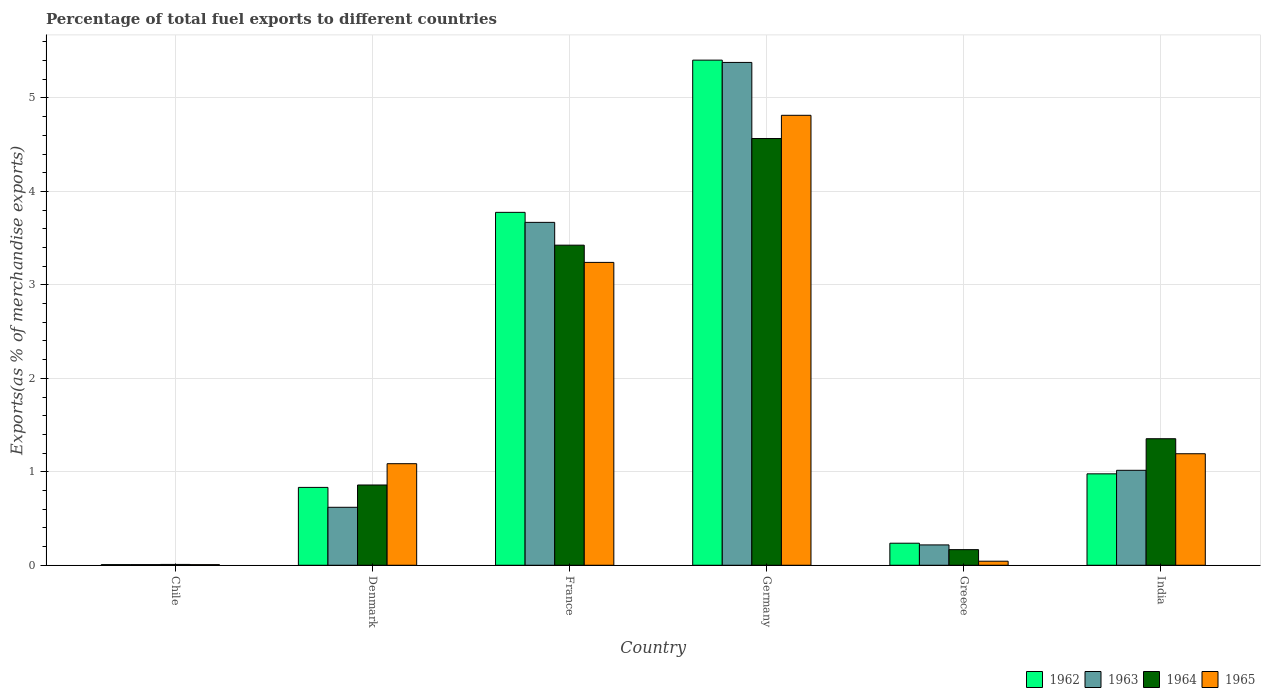How many bars are there on the 4th tick from the left?
Your answer should be compact. 4. What is the label of the 6th group of bars from the left?
Offer a very short reply. India. What is the percentage of exports to different countries in 1962 in Germany?
Keep it short and to the point. 5.4. Across all countries, what is the maximum percentage of exports to different countries in 1965?
Keep it short and to the point. 4.81. Across all countries, what is the minimum percentage of exports to different countries in 1963?
Your answer should be very brief. 0.01. In which country was the percentage of exports to different countries in 1965 minimum?
Offer a very short reply. Chile. What is the total percentage of exports to different countries in 1963 in the graph?
Ensure brevity in your answer.  10.91. What is the difference between the percentage of exports to different countries in 1962 in Greece and that in India?
Your answer should be compact. -0.74. What is the difference between the percentage of exports to different countries in 1963 in France and the percentage of exports to different countries in 1965 in India?
Make the answer very short. 2.48. What is the average percentage of exports to different countries in 1964 per country?
Your answer should be very brief. 1.73. What is the difference between the percentage of exports to different countries of/in 1965 and percentage of exports to different countries of/in 1962 in Germany?
Make the answer very short. -0.59. In how many countries, is the percentage of exports to different countries in 1964 greater than 2 %?
Your response must be concise. 2. What is the ratio of the percentage of exports to different countries in 1963 in Denmark to that in Germany?
Keep it short and to the point. 0.12. What is the difference between the highest and the second highest percentage of exports to different countries in 1965?
Your response must be concise. -2.05. What is the difference between the highest and the lowest percentage of exports to different countries in 1963?
Provide a short and direct response. 5.37. What does the 3rd bar from the right in Greece represents?
Your answer should be very brief. 1963. How many bars are there?
Make the answer very short. 24. Does the graph contain any zero values?
Offer a terse response. No. Does the graph contain grids?
Provide a short and direct response. Yes. How many legend labels are there?
Your answer should be very brief. 4. How are the legend labels stacked?
Your answer should be compact. Horizontal. What is the title of the graph?
Offer a very short reply. Percentage of total fuel exports to different countries. What is the label or title of the X-axis?
Offer a terse response. Country. What is the label or title of the Y-axis?
Make the answer very short. Exports(as % of merchandise exports). What is the Exports(as % of merchandise exports) in 1962 in Chile?
Your answer should be compact. 0.01. What is the Exports(as % of merchandise exports) in 1963 in Chile?
Offer a terse response. 0.01. What is the Exports(as % of merchandise exports) in 1964 in Chile?
Ensure brevity in your answer.  0.01. What is the Exports(as % of merchandise exports) of 1965 in Chile?
Offer a very short reply. 0.01. What is the Exports(as % of merchandise exports) in 1962 in Denmark?
Offer a terse response. 0.83. What is the Exports(as % of merchandise exports) in 1963 in Denmark?
Give a very brief answer. 0.62. What is the Exports(as % of merchandise exports) in 1964 in Denmark?
Provide a succinct answer. 0.86. What is the Exports(as % of merchandise exports) in 1965 in Denmark?
Give a very brief answer. 1.09. What is the Exports(as % of merchandise exports) of 1962 in France?
Give a very brief answer. 3.78. What is the Exports(as % of merchandise exports) of 1963 in France?
Your answer should be compact. 3.67. What is the Exports(as % of merchandise exports) of 1964 in France?
Keep it short and to the point. 3.43. What is the Exports(as % of merchandise exports) in 1965 in France?
Your answer should be compact. 3.24. What is the Exports(as % of merchandise exports) of 1962 in Germany?
Your answer should be very brief. 5.4. What is the Exports(as % of merchandise exports) of 1963 in Germany?
Offer a terse response. 5.38. What is the Exports(as % of merchandise exports) of 1964 in Germany?
Offer a very short reply. 4.57. What is the Exports(as % of merchandise exports) of 1965 in Germany?
Your response must be concise. 4.81. What is the Exports(as % of merchandise exports) of 1962 in Greece?
Make the answer very short. 0.24. What is the Exports(as % of merchandise exports) in 1963 in Greece?
Your response must be concise. 0.22. What is the Exports(as % of merchandise exports) of 1964 in Greece?
Give a very brief answer. 0.17. What is the Exports(as % of merchandise exports) of 1965 in Greece?
Provide a succinct answer. 0.04. What is the Exports(as % of merchandise exports) of 1962 in India?
Keep it short and to the point. 0.98. What is the Exports(as % of merchandise exports) in 1963 in India?
Ensure brevity in your answer.  1.02. What is the Exports(as % of merchandise exports) in 1964 in India?
Keep it short and to the point. 1.35. What is the Exports(as % of merchandise exports) of 1965 in India?
Offer a terse response. 1.19. Across all countries, what is the maximum Exports(as % of merchandise exports) of 1962?
Make the answer very short. 5.4. Across all countries, what is the maximum Exports(as % of merchandise exports) of 1963?
Provide a short and direct response. 5.38. Across all countries, what is the maximum Exports(as % of merchandise exports) in 1964?
Offer a terse response. 4.57. Across all countries, what is the maximum Exports(as % of merchandise exports) in 1965?
Provide a succinct answer. 4.81. Across all countries, what is the minimum Exports(as % of merchandise exports) of 1962?
Your response must be concise. 0.01. Across all countries, what is the minimum Exports(as % of merchandise exports) of 1963?
Give a very brief answer. 0.01. Across all countries, what is the minimum Exports(as % of merchandise exports) of 1964?
Give a very brief answer. 0.01. Across all countries, what is the minimum Exports(as % of merchandise exports) in 1965?
Ensure brevity in your answer.  0.01. What is the total Exports(as % of merchandise exports) in 1962 in the graph?
Your response must be concise. 11.24. What is the total Exports(as % of merchandise exports) of 1963 in the graph?
Your answer should be compact. 10.91. What is the total Exports(as % of merchandise exports) in 1964 in the graph?
Your answer should be very brief. 10.38. What is the total Exports(as % of merchandise exports) in 1965 in the graph?
Offer a terse response. 10.39. What is the difference between the Exports(as % of merchandise exports) of 1962 in Chile and that in Denmark?
Keep it short and to the point. -0.83. What is the difference between the Exports(as % of merchandise exports) of 1963 in Chile and that in Denmark?
Ensure brevity in your answer.  -0.61. What is the difference between the Exports(as % of merchandise exports) of 1964 in Chile and that in Denmark?
Your answer should be very brief. -0.85. What is the difference between the Exports(as % of merchandise exports) in 1965 in Chile and that in Denmark?
Keep it short and to the point. -1.08. What is the difference between the Exports(as % of merchandise exports) in 1962 in Chile and that in France?
Provide a short and direct response. -3.77. What is the difference between the Exports(as % of merchandise exports) of 1963 in Chile and that in France?
Keep it short and to the point. -3.66. What is the difference between the Exports(as % of merchandise exports) in 1964 in Chile and that in France?
Provide a succinct answer. -3.42. What is the difference between the Exports(as % of merchandise exports) in 1965 in Chile and that in France?
Your answer should be compact. -3.23. What is the difference between the Exports(as % of merchandise exports) in 1962 in Chile and that in Germany?
Offer a very short reply. -5.4. What is the difference between the Exports(as % of merchandise exports) in 1963 in Chile and that in Germany?
Offer a terse response. -5.37. What is the difference between the Exports(as % of merchandise exports) of 1964 in Chile and that in Germany?
Keep it short and to the point. -4.56. What is the difference between the Exports(as % of merchandise exports) in 1965 in Chile and that in Germany?
Offer a very short reply. -4.81. What is the difference between the Exports(as % of merchandise exports) in 1962 in Chile and that in Greece?
Your response must be concise. -0.23. What is the difference between the Exports(as % of merchandise exports) in 1963 in Chile and that in Greece?
Keep it short and to the point. -0.21. What is the difference between the Exports(as % of merchandise exports) in 1964 in Chile and that in Greece?
Make the answer very short. -0.16. What is the difference between the Exports(as % of merchandise exports) of 1965 in Chile and that in Greece?
Provide a succinct answer. -0.04. What is the difference between the Exports(as % of merchandise exports) in 1962 in Chile and that in India?
Your answer should be very brief. -0.97. What is the difference between the Exports(as % of merchandise exports) of 1963 in Chile and that in India?
Offer a very short reply. -1.01. What is the difference between the Exports(as % of merchandise exports) of 1964 in Chile and that in India?
Ensure brevity in your answer.  -1.34. What is the difference between the Exports(as % of merchandise exports) of 1965 in Chile and that in India?
Your response must be concise. -1.19. What is the difference between the Exports(as % of merchandise exports) in 1962 in Denmark and that in France?
Give a very brief answer. -2.94. What is the difference between the Exports(as % of merchandise exports) in 1963 in Denmark and that in France?
Make the answer very short. -3.05. What is the difference between the Exports(as % of merchandise exports) of 1964 in Denmark and that in France?
Your answer should be compact. -2.57. What is the difference between the Exports(as % of merchandise exports) of 1965 in Denmark and that in France?
Your answer should be very brief. -2.15. What is the difference between the Exports(as % of merchandise exports) of 1962 in Denmark and that in Germany?
Your answer should be compact. -4.57. What is the difference between the Exports(as % of merchandise exports) of 1963 in Denmark and that in Germany?
Make the answer very short. -4.76. What is the difference between the Exports(as % of merchandise exports) in 1964 in Denmark and that in Germany?
Your answer should be very brief. -3.71. What is the difference between the Exports(as % of merchandise exports) in 1965 in Denmark and that in Germany?
Provide a succinct answer. -3.73. What is the difference between the Exports(as % of merchandise exports) of 1962 in Denmark and that in Greece?
Keep it short and to the point. 0.6. What is the difference between the Exports(as % of merchandise exports) of 1963 in Denmark and that in Greece?
Ensure brevity in your answer.  0.4. What is the difference between the Exports(as % of merchandise exports) in 1964 in Denmark and that in Greece?
Make the answer very short. 0.69. What is the difference between the Exports(as % of merchandise exports) in 1965 in Denmark and that in Greece?
Give a very brief answer. 1.04. What is the difference between the Exports(as % of merchandise exports) in 1962 in Denmark and that in India?
Your answer should be very brief. -0.14. What is the difference between the Exports(as % of merchandise exports) of 1963 in Denmark and that in India?
Make the answer very short. -0.4. What is the difference between the Exports(as % of merchandise exports) of 1964 in Denmark and that in India?
Give a very brief answer. -0.49. What is the difference between the Exports(as % of merchandise exports) in 1965 in Denmark and that in India?
Provide a succinct answer. -0.11. What is the difference between the Exports(as % of merchandise exports) in 1962 in France and that in Germany?
Ensure brevity in your answer.  -1.63. What is the difference between the Exports(as % of merchandise exports) in 1963 in France and that in Germany?
Your response must be concise. -1.71. What is the difference between the Exports(as % of merchandise exports) in 1964 in France and that in Germany?
Your response must be concise. -1.14. What is the difference between the Exports(as % of merchandise exports) in 1965 in France and that in Germany?
Provide a succinct answer. -1.57. What is the difference between the Exports(as % of merchandise exports) in 1962 in France and that in Greece?
Keep it short and to the point. 3.54. What is the difference between the Exports(as % of merchandise exports) of 1963 in France and that in Greece?
Make the answer very short. 3.45. What is the difference between the Exports(as % of merchandise exports) in 1964 in France and that in Greece?
Keep it short and to the point. 3.26. What is the difference between the Exports(as % of merchandise exports) in 1965 in France and that in Greece?
Keep it short and to the point. 3.2. What is the difference between the Exports(as % of merchandise exports) in 1962 in France and that in India?
Give a very brief answer. 2.8. What is the difference between the Exports(as % of merchandise exports) in 1963 in France and that in India?
Ensure brevity in your answer.  2.65. What is the difference between the Exports(as % of merchandise exports) of 1964 in France and that in India?
Give a very brief answer. 2.07. What is the difference between the Exports(as % of merchandise exports) of 1965 in France and that in India?
Ensure brevity in your answer.  2.05. What is the difference between the Exports(as % of merchandise exports) in 1962 in Germany and that in Greece?
Ensure brevity in your answer.  5.17. What is the difference between the Exports(as % of merchandise exports) in 1963 in Germany and that in Greece?
Ensure brevity in your answer.  5.16. What is the difference between the Exports(as % of merchandise exports) of 1964 in Germany and that in Greece?
Offer a terse response. 4.4. What is the difference between the Exports(as % of merchandise exports) of 1965 in Germany and that in Greece?
Ensure brevity in your answer.  4.77. What is the difference between the Exports(as % of merchandise exports) of 1962 in Germany and that in India?
Your answer should be very brief. 4.43. What is the difference between the Exports(as % of merchandise exports) of 1963 in Germany and that in India?
Provide a succinct answer. 4.36. What is the difference between the Exports(as % of merchandise exports) in 1964 in Germany and that in India?
Offer a terse response. 3.21. What is the difference between the Exports(as % of merchandise exports) in 1965 in Germany and that in India?
Your answer should be very brief. 3.62. What is the difference between the Exports(as % of merchandise exports) in 1962 in Greece and that in India?
Your response must be concise. -0.74. What is the difference between the Exports(as % of merchandise exports) of 1963 in Greece and that in India?
Provide a succinct answer. -0.8. What is the difference between the Exports(as % of merchandise exports) of 1964 in Greece and that in India?
Provide a succinct answer. -1.19. What is the difference between the Exports(as % of merchandise exports) in 1965 in Greece and that in India?
Offer a terse response. -1.15. What is the difference between the Exports(as % of merchandise exports) of 1962 in Chile and the Exports(as % of merchandise exports) of 1963 in Denmark?
Ensure brevity in your answer.  -0.61. What is the difference between the Exports(as % of merchandise exports) of 1962 in Chile and the Exports(as % of merchandise exports) of 1964 in Denmark?
Make the answer very short. -0.85. What is the difference between the Exports(as % of merchandise exports) in 1962 in Chile and the Exports(as % of merchandise exports) in 1965 in Denmark?
Provide a short and direct response. -1.08. What is the difference between the Exports(as % of merchandise exports) in 1963 in Chile and the Exports(as % of merchandise exports) in 1964 in Denmark?
Offer a very short reply. -0.85. What is the difference between the Exports(as % of merchandise exports) in 1963 in Chile and the Exports(as % of merchandise exports) in 1965 in Denmark?
Provide a succinct answer. -1.08. What is the difference between the Exports(as % of merchandise exports) of 1964 in Chile and the Exports(as % of merchandise exports) of 1965 in Denmark?
Provide a succinct answer. -1.08. What is the difference between the Exports(as % of merchandise exports) in 1962 in Chile and the Exports(as % of merchandise exports) in 1963 in France?
Your answer should be very brief. -3.66. What is the difference between the Exports(as % of merchandise exports) of 1962 in Chile and the Exports(as % of merchandise exports) of 1964 in France?
Offer a very short reply. -3.42. What is the difference between the Exports(as % of merchandise exports) in 1962 in Chile and the Exports(as % of merchandise exports) in 1965 in France?
Provide a short and direct response. -3.23. What is the difference between the Exports(as % of merchandise exports) of 1963 in Chile and the Exports(as % of merchandise exports) of 1964 in France?
Your answer should be very brief. -3.42. What is the difference between the Exports(as % of merchandise exports) of 1963 in Chile and the Exports(as % of merchandise exports) of 1965 in France?
Make the answer very short. -3.23. What is the difference between the Exports(as % of merchandise exports) in 1964 in Chile and the Exports(as % of merchandise exports) in 1965 in France?
Your answer should be very brief. -3.23. What is the difference between the Exports(as % of merchandise exports) in 1962 in Chile and the Exports(as % of merchandise exports) in 1963 in Germany?
Your response must be concise. -5.37. What is the difference between the Exports(as % of merchandise exports) in 1962 in Chile and the Exports(as % of merchandise exports) in 1964 in Germany?
Keep it short and to the point. -4.56. What is the difference between the Exports(as % of merchandise exports) of 1962 in Chile and the Exports(as % of merchandise exports) of 1965 in Germany?
Your response must be concise. -4.81. What is the difference between the Exports(as % of merchandise exports) in 1963 in Chile and the Exports(as % of merchandise exports) in 1964 in Germany?
Offer a terse response. -4.56. What is the difference between the Exports(as % of merchandise exports) in 1963 in Chile and the Exports(as % of merchandise exports) in 1965 in Germany?
Provide a succinct answer. -4.81. What is the difference between the Exports(as % of merchandise exports) of 1964 in Chile and the Exports(as % of merchandise exports) of 1965 in Germany?
Your answer should be very brief. -4.81. What is the difference between the Exports(as % of merchandise exports) of 1962 in Chile and the Exports(as % of merchandise exports) of 1963 in Greece?
Make the answer very short. -0.21. What is the difference between the Exports(as % of merchandise exports) of 1962 in Chile and the Exports(as % of merchandise exports) of 1964 in Greece?
Ensure brevity in your answer.  -0.16. What is the difference between the Exports(as % of merchandise exports) of 1962 in Chile and the Exports(as % of merchandise exports) of 1965 in Greece?
Ensure brevity in your answer.  -0.04. What is the difference between the Exports(as % of merchandise exports) in 1963 in Chile and the Exports(as % of merchandise exports) in 1964 in Greece?
Ensure brevity in your answer.  -0.16. What is the difference between the Exports(as % of merchandise exports) of 1963 in Chile and the Exports(as % of merchandise exports) of 1965 in Greece?
Make the answer very short. -0.04. What is the difference between the Exports(as % of merchandise exports) of 1964 in Chile and the Exports(as % of merchandise exports) of 1965 in Greece?
Your answer should be very brief. -0.03. What is the difference between the Exports(as % of merchandise exports) in 1962 in Chile and the Exports(as % of merchandise exports) in 1963 in India?
Provide a succinct answer. -1.01. What is the difference between the Exports(as % of merchandise exports) of 1962 in Chile and the Exports(as % of merchandise exports) of 1964 in India?
Provide a short and direct response. -1.35. What is the difference between the Exports(as % of merchandise exports) of 1962 in Chile and the Exports(as % of merchandise exports) of 1965 in India?
Offer a terse response. -1.19. What is the difference between the Exports(as % of merchandise exports) of 1963 in Chile and the Exports(as % of merchandise exports) of 1964 in India?
Ensure brevity in your answer.  -1.35. What is the difference between the Exports(as % of merchandise exports) of 1963 in Chile and the Exports(as % of merchandise exports) of 1965 in India?
Provide a succinct answer. -1.19. What is the difference between the Exports(as % of merchandise exports) of 1964 in Chile and the Exports(as % of merchandise exports) of 1965 in India?
Provide a short and direct response. -1.18. What is the difference between the Exports(as % of merchandise exports) of 1962 in Denmark and the Exports(as % of merchandise exports) of 1963 in France?
Your response must be concise. -2.84. What is the difference between the Exports(as % of merchandise exports) in 1962 in Denmark and the Exports(as % of merchandise exports) in 1964 in France?
Your response must be concise. -2.59. What is the difference between the Exports(as % of merchandise exports) of 1962 in Denmark and the Exports(as % of merchandise exports) of 1965 in France?
Provide a succinct answer. -2.41. What is the difference between the Exports(as % of merchandise exports) of 1963 in Denmark and the Exports(as % of merchandise exports) of 1964 in France?
Keep it short and to the point. -2.8. What is the difference between the Exports(as % of merchandise exports) of 1963 in Denmark and the Exports(as % of merchandise exports) of 1965 in France?
Ensure brevity in your answer.  -2.62. What is the difference between the Exports(as % of merchandise exports) of 1964 in Denmark and the Exports(as % of merchandise exports) of 1965 in France?
Offer a very short reply. -2.38. What is the difference between the Exports(as % of merchandise exports) in 1962 in Denmark and the Exports(as % of merchandise exports) in 1963 in Germany?
Your answer should be compact. -4.55. What is the difference between the Exports(as % of merchandise exports) of 1962 in Denmark and the Exports(as % of merchandise exports) of 1964 in Germany?
Your answer should be very brief. -3.73. What is the difference between the Exports(as % of merchandise exports) in 1962 in Denmark and the Exports(as % of merchandise exports) in 1965 in Germany?
Ensure brevity in your answer.  -3.98. What is the difference between the Exports(as % of merchandise exports) in 1963 in Denmark and the Exports(as % of merchandise exports) in 1964 in Germany?
Your answer should be very brief. -3.95. What is the difference between the Exports(as % of merchandise exports) of 1963 in Denmark and the Exports(as % of merchandise exports) of 1965 in Germany?
Keep it short and to the point. -4.19. What is the difference between the Exports(as % of merchandise exports) in 1964 in Denmark and the Exports(as % of merchandise exports) in 1965 in Germany?
Your answer should be very brief. -3.96. What is the difference between the Exports(as % of merchandise exports) of 1962 in Denmark and the Exports(as % of merchandise exports) of 1963 in Greece?
Your answer should be very brief. 0.62. What is the difference between the Exports(as % of merchandise exports) of 1962 in Denmark and the Exports(as % of merchandise exports) of 1964 in Greece?
Keep it short and to the point. 0.67. What is the difference between the Exports(as % of merchandise exports) of 1962 in Denmark and the Exports(as % of merchandise exports) of 1965 in Greece?
Keep it short and to the point. 0.79. What is the difference between the Exports(as % of merchandise exports) of 1963 in Denmark and the Exports(as % of merchandise exports) of 1964 in Greece?
Your answer should be compact. 0.45. What is the difference between the Exports(as % of merchandise exports) in 1963 in Denmark and the Exports(as % of merchandise exports) in 1965 in Greece?
Your response must be concise. 0.58. What is the difference between the Exports(as % of merchandise exports) in 1964 in Denmark and the Exports(as % of merchandise exports) in 1965 in Greece?
Your answer should be very brief. 0.82. What is the difference between the Exports(as % of merchandise exports) of 1962 in Denmark and the Exports(as % of merchandise exports) of 1963 in India?
Your answer should be very brief. -0.18. What is the difference between the Exports(as % of merchandise exports) of 1962 in Denmark and the Exports(as % of merchandise exports) of 1964 in India?
Make the answer very short. -0.52. What is the difference between the Exports(as % of merchandise exports) in 1962 in Denmark and the Exports(as % of merchandise exports) in 1965 in India?
Your answer should be very brief. -0.36. What is the difference between the Exports(as % of merchandise exports) of 1963 in Denmark and the Exports(as % of merchandise exports) of 1964 in India?
Ensure brevity in your answer.  -0.73. What is the difference between the Exports(as % of merchandise exports) in 1963 in Denmark and the Exports(as % of merchandise exports) in 1965 in India?
Make the answer very short. -0.57. What is the difference between the Exports(as % of merchandise exports) of 1964 in Denmark and the Exports(as % of merchandise exports) of 1965 in India?
Offer a very short reply. -0.33. What is the difference between the Exports(as % of merchandise exports) in 1962 in France and the Exports(as % of merchandise exports) in 1963 in Germany?
Keep it short and to the point. -1.6. What is the difference between the Exports(as % of merchandise exports) of 1962 in France and the Exports(as % of merchandise exports) of 1964 in Germany?
Ensure brevity in your answer.  -0.79. What is the difference between the Exports(as % of merchandise exports) of 1962 in France and the Exports(as % of merchandise exports) of 1965 in Germany?
Your response must be concise. -1.04. What is the difference between the Exports(as % of merchandise exports) of 1963 in France and the Exports(as % of merchandise exports) of 1964 in Germany?
Give a very brief answer. -0.9. What is the difference between the Exports(as % of merchandise exports) in 1963 in France and the Exports(as % of merchandise exports) in 1965 in Germany?
Your response must be concise. -1.15. What is the difference between the Exports(as % of merchandise exports) of 1964 in France and the Exports(as % of merchandise exports) of 1965 in Germany?
Provide a short and direct response. -1.39. What is the difference between the Exports(as % of merchandise exports) in 1962 in France and the Exports(as % of merchandise exports) in 1963 in Greece?
Offer a terse response. 3.56. What is the difference between the Exports(as % of merchandise exports) of 1962 in France and the Exports(as % of merchandise exports) of 1964 in Greece?
Keep it short and to the point. 3.61. What is the difference between the Exports(as % of merchandise exports) in 1962 in France and the Exports(as % of merchandise exports) in 1965 in Greece?
Provide a short and direct response. 3.73. What is the difference between the Exports(as % of merchandise exports) of 1963 in France and the Exports(as % of merchandise exports) of 1964 in Greece?
Make the answer very short. 3.5. What is the difference between the Exports(as % of merchandise exports) of 1963 in France and the Exports(as % of merchandise exports) of 1965 in Greece?
Provide a short and direct response. 3.63. What is the difference between the Exports(as % of merchandise exports) in 1964 in France and the Exports(as % of merchandise exports) in 1965 in Greece?
Ensure brevity in your answer.  3.38. What is the difference between the Exports(as % of merchandise exports) in 1962 in France and the Exports(as % of merchandise exports) in 1963 in India?
Offer a terse response. 2.76. What is the difference between the Exports(as % of merchandise exports) of 1962 in France and the Exports(as % of merchandise exports) of 1964 in India?
Make the answer very short. 2.42. What is the difference between the Exports(as % of merchandise exports) in 1962 in France and the Exports(as % of merchandise exports) in 1965 in India?
Keep it short and to the point. 2.58. What is the difference between the Exports(as % of merchandise exports) of 1963 in France and the Exports(as % of merchandise exports) of 1964 in India?
Give a very brief answer. 2.32. What is the difference between the Exports(as % of merchandise exports) of 1963 in France and the Exports(as % of merchandise exports) of 1965 in India?
Offer a terse response. 2.48. What is the difference between the Exports(as % of merchandise exports) in 1964 in France and the Exports(as % of merchandise exports) in 1965 in India?
Ensure brevity in your answer.  2.23. What is the difference between the Exports(as % of merchandise exports) in 1962 in Germany and the Exports(as % of merchandise exports) in 1963 in Greece?
Give a very brief answer. 5.19. What is the difference between the Exports(as % of merchandise exports) in 1962 in Germany and the Exports(as % of merchandise exports) in 1964 in Greece?
Your answer should be compact. 5.24. What is the difference between the Exports(as % of merchandise exports) of 1962 in Germany and the Exports(as % of merchandise exports) of 1965 in Greece?
Provide a succinct answer. 5.36. What is the difference between the Exports(as % of merchandise exports) of 1963 in Germany and the Exports(as % of merchandise exports) of 1964 in Greece?
Offer a very short reply. 5.21. What is the difference between the Exports(as % of merchandise exports) of 1963 in Germany and the Exports(as % of merchandise exports) of 1965 in Greece?
Your answer should be very brief. 5.34. What is the difference between the Exports(as % of merchandise exports) in 1964 in Germany and the Exports(as % of merchandise exports) in 1965 in Greece?
Your answer should be very brief. 4.52. What is the difference between the Exports(as % of merchandise exports) in 1962 in Germany and the Exports(as % of merchandise exports) in 1963 in India?
Provide a short and direct response. 4.39. What is the difference between the Exports(as % of merchandise exports) of 1962 in Germany and the Exports(as % of merchandise exports) of 1964 in India?
Provide a short and direct response. 4.05. What is the difference between the Exports(as % of merchandise exports) of 1962 in Germany and the Exports(as % of merchandise exports) of 1965 in India?
Your answer should be compact. 4.21. What is the difference between the Exports(as % of merchandise exports) of 1963 in Germany and the Exports(as % of merchandise exports) of 1964 in India?
Give a very brief answer. 4.03. What is the difference between the Exports(as % of merchandise exports) of 1963 in Germany and the Exports(as % of merchandise exports) of 1965 in India?
Your answer should be very brief. 4.19. What is the difference between the Exports(as % of merchandise exports) of 1964 in Germany and the Exports(as % of merchandise exports) of 1965 in India?
Keep it short and to the point. 3.37. What is the difference between the Exports(as % of merchandise exports) in 1962 in Greece and the Exports(as % of merchandise exports) in 1963 in India?
Ensure brevity in your answer.  -0.78. What is the difference between the Exports(as % of merchandise exports) in 1962 in Greece and the Exports(as % of merchandise exports) in 1964 in India?
Your answer should be compact. -1.12. What is the difference between the Exports(as % of merchandise exports) of 1962 in Greece and the Exports(as % of merchandise exports) of 1965 in India?
Offer a very short reply. -0.96. What is the difference between the Exports(as % of merchandise exports) of 1963 in Greece and the Exports(as % of merchandise exports) of 1964 in India?
Make the answer very short. -1.14. What is the difference between the Exports(as % of merchandise exports) of 1963 in Greece and the Exports(as % of merchandise exports) of 1965 in India?
Make the answer very short. -0.98. What is the difference between the Exports(as % of merchandise exports) in 1964 in Greece and the Exports(as % of merchandise exports) in 1965 in India?
Make the answer very short. -1.03. What is the average Exports(as % of merchandise exports) of 1962 per country?
Your answer should be very brief. 1.87. What is the average Exports(as % of merchandise exports) in 1963 per country?
Your answer should be very brief. 1.82. What is the average Exports(as % of merchandise exports) of 1964 per country?
Your response must be concise. 1.73. What is the average Exports(as % of merchandise exports) of 1965 per country?
Make the answer very short. 1.73. What is the difference between the Exports(as % of merchandise exports) in 1962 and Exports(as % of merchandise exports) in 1963 in Chile?
Keep it short and to the point. -0. What is the difference between the Exports(as % of merchandise exports) in 1962 and Exports(as % of merchandise exports) in 1964 in Chile?
Your response must be concise. -0. What is the difference between the Exports(as % of merchandise exports) in 1963 and Exports(as % of merchandise exports) in 1964 in Chile?
Ensure brevity in your answer.  -0. What is the difference between the Exports(as % of merchandise exports) in 1964 and Exports(as % of merchandise exports) in 1965 in Chile?
Your answer should be compact. 0. What is the difference between the Exports(as % of merchandise exports) in 1962 and Exports(as % of merchandise exports) in 1963 in Denmark?
Ensure brevity in your answer.  0.21. What is the difference between the Exports(as % of merchandise exports) in 1962 and Exports(as % of merchandise exports) in 1964 in Denmark?
Your answer should be very brief. -0.03. What is the difference between the Exports(as % of merchandise exports) of 1962 and Exports(as % of merchandise exports) of 1965 in Denmark?
Offer a terse response. -0.25. What is the difference between the Exports(as % of merchandise exports) in 1963 and Exports(as % of merchandise exports) in 1964 in Denmark?
Your response must be concise. -0.24. What is the difference between the Exports(as % of merchandise exports) in 1963 and Exports(as % of merchandise exports) in 1965 in Denmark?
Give a very brief answer. -0.47. What is the difference between the Exports(as % of merchandise exports) in 1964 and Exports(as % of merchandise exports) in 1965 in Denmark?
Your answer should be very brief. -0.23. What is the difference between the Exports(as % of merchandise exports) of 1962 and Exports(as % of merchandise exports) of 1963 in France?
Make the answer very short. 0.11. What is the difference between the Exports(as % of merchandise exports) of 1962 and Exports(as % of merchandise exports) of 1964 in France?
Keep it short and to the point. 0.35. What is the difference between the Exports(as % of merchandise exports) of 1962 and Exports(as % of merchandise exports) of 1965 in France?
Make the answer very short. 0.54. What is the difference between the Exports(as % of merchandise exports) in 1963 and Exports(as % of merchandise exports) in 1964 in France?
Offer a terse response. 0.24. What is the difference between the Exports(as % of merchandise exports) of 1963 and Exports(as % of merchandise exports) of 1965 in France?
Keep it short and to the point. 0.43. What is the difference between the Exports(as % of merchandise exports) of 1964 and Exports(as % of merchandise exports) of 1965 in France?
Your answer should be very brief. 0.18. What is the difference between the Exports(as % of merchandise exports) of 1962 and Exports(as % of merchandise exports) of 1963 in Germany?
Offer a very short reply. 0.02. What is the difference between the Exports(as % of merchandise exports) of 1962 and Exports(as % of merchandise exports) of 1964 in Germany?
Offer a very short reply. 0.84. What is the difference between the Exports(as % of merchandise exports) in 1962 and Exports(as % of merchandise exports) in 1965 in Germany?
Provide a short and direct response. 0.59. What is the difference between the Exports(as % of merchandise exports) in 1963 and Exports(as % of merchandise exports) in 1964 in Germany?
Ensure brevity in your answer.  0.81. What is the difference between the Exports(as % of merchandise exports) in 1963 and Exports(as % of merchandise exports) in 1965 in Germany?
Your response must be concise. 0.57. What is the difference between the Exports(as % of merchandise exports) in 1964 and Exports(as % of merchandise exports) in 1965 in Germany?
Your answer should be very brief. -0.25. What is the difference between the Exports(as % of merchandise exports) of 1962 and Exports(as % of merchandise exports) of 1963 in Greece?
Offer a very short reply. 0.02. What is the difference between the Exports(as % of merchandise exports) in 1962 and Exports(as % of merchandise exports) in 1964 in Greece?
Provide a short and direct response. 0.07. What is the difference between the Exports(as % of merchandise exports) in 1962 and Exports(as % of merchandise exports) in 1965 in Greece?
Ensure brevity in your answer.  0.19. What is the difference between the Exports(as % of merchandise exports) in 1963 and Exports(as % of merchandise exports) in 1964 in Greece?
Provide a short and direct response. 0.05. What is the difference between the Exports(as % of merchandise exports) of 1963 and Exports(as % of merchandise exports) of 1965 in Greece?
Keep it short and to the point. 0.17. What is the difference between the Exports(as % of merchandise exports) of 1964 and Exports(as % of merchandise exports) of 1965 in Greece?
Keep it short and to the point. 0.12. What is the difference between the Exports(as % of merchandise exports) of 1962 and Exports(as % of merchandise exports) of 1963 in India?
Make the answer very short. -0.04. What is the difference between the Exports(as % of merchandise exports) in 1962 and Exports(as % of merchandise exports) in 1964 in India?
Offer a terse response. -0.38. What is the difference between the Exports(as % of merchandise exports) in 1962 and Exports(as % of merchandise exports) in 1965 in India?
Keep it short and to the point. -0.22. What is the difference between the Exports(as % of merchandise exports) of 1963 and Exports(as % of merchandise exports) of 1964 in India?
Offer a terse response. -0.34. What is the difference between the Exports(as % of merchandise exports) in 1963 and Exports(as % of merchandise exports) in 1965 in India?
Your response must be concise. -0.18. What is the difference between the Exports(as % of merchandise exports) in 1964 and Exports(as % of merchandise exports) in 1965 in India?
Offer a very short reply. 0.16. What is the ratio of the Exports(as % of merchandise exports) in 1962 in Chile to that in Denmark?
Your response must be concise. 0.01. What is the ratio of the Exports(as % of merchandise exports) in 1963 in Chile to that in Denmark?
Ensure brevity in your answer.  0.01. What is the ratio of the Exports(as % of merchandise exports) of 1964 in Chile to that in Denmark?
Your response must be concise. 0.01. What is the ratio of the Exports(as % of merchandise exports) in 1965 in Chile to that in Denmark?
Your response must be concise. 0.01. What is the ratio of the Exports(as % of merchandise exports) of 1962 in Chile to that in France?
Your answer should be very brief. 0. What is the ratio of the Exports(as % of merchandise exports) in 1963 in Chile to that in France?
Keep it short and to the point. 0. What is the ratio of the Exports(as % of merchandise exports) in 1964 in Chile to that in France?
Ensure brevity in your answer.  0. What is the ratio of the Exports(as % of merchandise exports) of 1965 in Chile to that in France?
Provide a short and direct response. 0. What is the ratio of the Exports(as % of merchandise exports) of 1962 in Chile to that in Germany?
Your answer should be compact. 0. What is the ratio of the Exports(as % of merchandise exports) in 1963 in Chile to that in Germany?
Make the answer very short. 0. What is the ratio of the Exports(as % of merchandise exports) in 1964 in Chile to that in Germany?
Give a very brief answer. 0. What is the ratio of the Exports(as % of merchandise exports) in 1965 in Chile to that in Germany?
Ensure brevity in your answer.  0. What is the ratio of the Exports(as % of merchandise exports) of 1962 in Chile to that in Greece?
Offer a very short reply. 0.03. What is the ratio of the Exports(as % of merchandise exports) of 1963 in Chile to that in Greece?
Offer a terse response. 0.03. What is the ratio of the Exports(as % of merchandise exports) in 1964 in Chile to that in Greece?
Provide a short and direct response. 0.05. What is the ratio of the Exports(as % of merchandise exports) in 1965 in Chile to that in Greece?
Offer a terse response. 0.16. What is the ratio of the Exports(as % of merchandise exports) of 1962 in Chile to that in India?
Keep it short and to the point. 0.01. What is the ratio of the Exports(as % of merchandise exports) of 1963 in Chile to that in India?
Provide a succinct answer. 0.01. What is the ratio of the Exports(as % of merchandise exports) in 1964 in Chile to that in India?
Your answer should be compact. 0.01. What is the ratio of the Exports(as % of merchandise exports) in 1965 in Chile to that in India?
Your response must be concise. 0.01. What is the ratio of the Exports(as % of merchandise exports) in 1962 in Denmark to that in France?
Give a very brief answer. 0.22. What is the ratio of the Exports(as % of merchandise exports) of 1963 in Denmark to that in France?
Your answer should be very brief. 0.17. What is the ratio of the Exports(as % of merchandise exports) in 1964 in Denmark to that in France?
Give a very brief answer. 0.25. What is the ratio of the Exports(as % of merchandise exports) in 1965 in Denmark to that in France?
Provide a short and direct response. 0.34. What is the ratio of the Exports(as % of merchandise exports) in 1962 in Denmark to that in Germany?
Ensure brevity in your answer.  0.15. What is the ratio of the Exports(as % of merchandise exports) of 1963 in Denmark to that in Germany?
Your response must be concise. 0.12. What is the ratio of the Exports(as % of merchandise exports) of 1964 in Denmark to that in Germany?
Your answer should be compact. 0.19. What is the ratio of the Exports(as % of merchandise exports) of 1965 in Denmark to that in Germany?
Provide a succinct answer. 0.23. What is the ratio of the Exports(as % of merchandise exports) in 1962 in Denmark to that in Greece?
Offer a terse response. 3.53. What is the ratio of the Exports(as % of merchandise exports) of 1963 in Denmark to that in Greece?
Provide a succinct answer. 2.85. What is the ratio of the Exports(as % of merchandise exports) in 1964 in Denmark to that in Greece?
Your answer should be very brief. 5.14. What is the ratio of the Exports(as % of merchandise exports) in 1965 in Denmark to that in Greece?
Offer a terse response. 25.05. What is the ratio of the Exports(as % of merchandise exports) in 1962 in Denmark to that in India?
Ensure brevity in your answer.  0.85. What is the ratio of the Exports(as % of merchandise exports) in 1963 in Denmark to that in India?
Offer a terse response. 0.61. What is the ratio of the Exports(as % of merchandise exports) in 1964 in Denmark to that in India?
Offer a terse response. 0.63. What is the ratio of the Exports(as % of merchandise exports) in 1965 in Denmark to that in India?
Provide a short and direct response. 0.91. What is the ratio of the Exports(as % of merchandise exports) of 1962 in France to that in Germany?
Ensure brevity in your answer.  0.7. What is the ratio of the Exports(as % of merchandise exports) of 1963 in France to that in Germany?
Provide a short and direct response. 0.68. What is the ratio of the Exports(as % of merchandise exports) of 1964 in France to that in Germany?
Offer a terse response. 0.75. What is the ratio of the Exports(as % of merchandise exports) in 1965 in France to that in Germany?
Offer a terse response. 0.67. What is the ratio of the Exports(as % of merchandise exports) of 1962 in France to that in Greece?
Your answer should be very brief. 16.01. What is the ratio of the Exports(as % of merchandise exports) of 1963 in France to that in Greece?
Offer a terse response. 16.85. What is the ratio of the Exports(as % of merchandise exports) in 1964 in France to that in Greece?
Give a very brief answer. 20.5. What is the ratio of the Exports(as % of merchandise exports) of 1965 in France to that in Greece?
Keep it short and to the point. 74.69. What is the ratio of the Exports(as % of merchandise exports) in 1962 in France to that in India?
Offer a terse response. 3.86. What is the ratio of the Exports(as % of merchandise exports) of 1963 in France to that in India?
Offer a very short reply. 3.61. What is the ratio of the Exports(as % of merchandise exports) of 1964 in France to that in India?
Make the answer very short. 2.53. What is the ratio of the Exports(as % of merchandise exports) in 1965 in France to that in India?
Your answer should be very brief. 2.72. What is the ratio of the Exports(as % of merchandise exports) of 1962 in Germany to that in Greece?
Offer a terse response. 22.91. What is the ratio of the Exports(as % of merchandise exports) of 1963 in Germany to that in Greece?
Provide a succinct answer. 24.71. What is the ratio of the Exports(as % of merchandise exports) in 1964 in Germany to that in Greece?
Make the answer very short. 27.34. What is the ratio of the Exports(as % of merchandise exports) of 1965 in Germany to that in Greece?
Your answer should be compact. 110.96. What is the ratio of the Exports(as % of merchandise exports) in 1962 in Germany to that in India?
Make the answer very short. 5.53. What is the ratio of the Exports(as % of merchandise exports) in 1963 in Germany to that in India?
Your answer should be compact. 5.3. What is the ratio of the Exports(as % of merchandise exports) of 1964 in Germany to that in India?
Keep it short and to the point. 3.37. What is the ratio of the Exports(as % of merchandise exports) in 1965 in Germany to that in India?
Provide a short and direct response. 4.03. What is the ratio of the Exports(as % of merchandise exports) of 1962 in Greece to that in India?
Give a very brief answer. 0.24. What is the ratio of the Exports(as % of merchandise exports) in 1963 in Greece to that in India?
Give a very brief answer. 0.21. What is the ratio of the Exports(as % of merchandise exports) of 1964 in Greece to that in India?
Give a very brief answer. 0.12. What is the ratio of the Exports(as % of merchandise exports) of 1965 in Greece to that in India?
Offer a very short reply. 0.04. What is the difference between the highest and the second highest Exports(as % of merchandise exports) in 1962?
Keep it short and to the point. 1.63. What is the difference between the highest and the second highest Exports(as % of merchandise exports) of 1963?
Your answer should be very brief. 1.71. What is the difference between the highest and the second highest Exports(as % of merchandise exports) in 1964?
Ensure brevity in your answer.  1.14. What is the difference between the highest and the second highest Exports(as % of merchandise exports) of 1965?
Ensure brevity in your answer.  1.57. What is the difference between the highest and the lowest Exports(as % of merchandise exports) in 1962?
Offer a very short reply. 5.4. What is the difference between the highest and the lowest Exports(as % of merchandise exports) of 1963?
Ensure brevity in your answer.  5.37. What is the difference between the highest and the lowest Exports(as % of merchandise exports) of 1964?
Your answer should be very brief. 4.56. What is the difference between the highest and the lowest Exports(as % of merchandise exports) of 1965?
Your response must be concise. 4.81. 